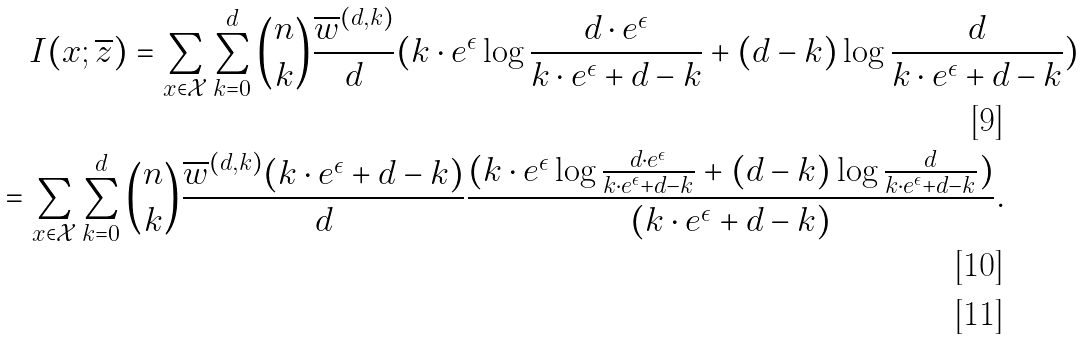<formula> <loc_0><loc_0><loc_500><loc_500>& \quad I ( x ; \overline { z } ) = \sum _ { x \in \mathcal { X } } \sum _ { k = 0 } ^ { d } { n \choose k } \frac { \overline { w } ^ { ( d , k ) } } { d } ( k \cdot e ^ { \epsilon } \log { \frac { d \cdot e ^ { \epsilon } } { k \cdot e ^ { \epsilon } + d - k } } + ( d - k ) \log { \frac { d } { k \cdot e ^ { \epsilon } + d - k } } ) & \\ & = \sum _ { x \in \mathcal { X } } \sum _ { k = 0 } ^ { d } { n \choose k } \frac { \overline { w } ^ { ( d , k ) } ( k \cdot e ^ { \epsilon } + d - k ) } { d } \frac { ( k \cdot e ^ { \epsilon } \log { \frac { d \cdot e ^ { \epsilon } } { k \cdot e ^ { \epsilon } + d - k } } + ( d - k ) \log { \frac { d } { k \cdot e ^ { \epsilon } + d - k } } ) } { ( k \cdot e ^ { \epsilon } + d - k ) } . & \\</formula> 